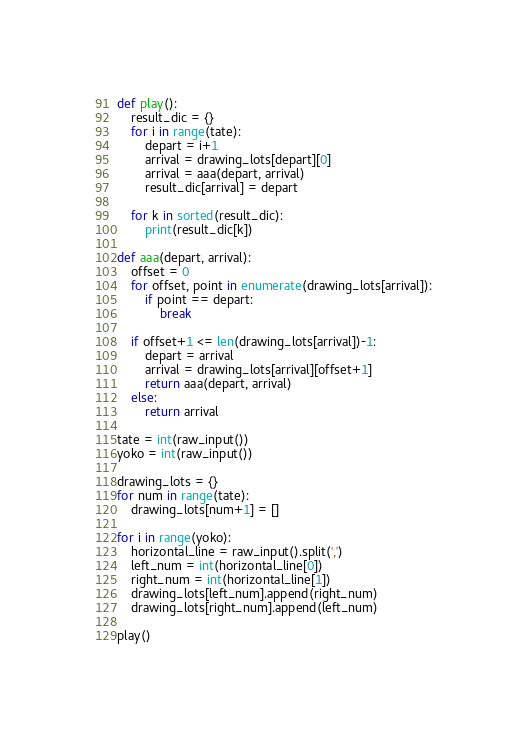<code> <loc_0><loc_0><loc_500><loc_500><_Python_>def play():
    result_dic = {}    
    for i in range(tate):
        depart = i+1
        arrival = drawing_lots[depart][0]
        arrival = aaa(depart, arrival)
        result_dic[arrival] = depart
    
    for k in sorted(result_dic):
        print(result_dic[k])

def aaa(depart, arrival):
    offset = 0
    for offset, point in enumerate(drawing_lots[arrival]):
        if point == depart:
            break
    
    if offset+1 <= len(drawing_lots[arrival])-1:
        depart = arrival
        arrival = drawing_lots[arrival][offset+1]
        return aaa(depart, arrival)
    else:
        return arrival
        
tate = int(raw_input())
yoko = int(raw_input())

drawing_lots = {}
for num in range(tate):
    drawing_lots[num+1] = []
    
for i in range(yoko):
    horizontal_line = raw_input().split(',')
    left_num = int(horizontal_line[0])
    right_num = int(horizontal_line[1])
    drawing_lots[left_num].append(right_num)
    drawing_lots[right_num].append(left_num)

play()</code> 